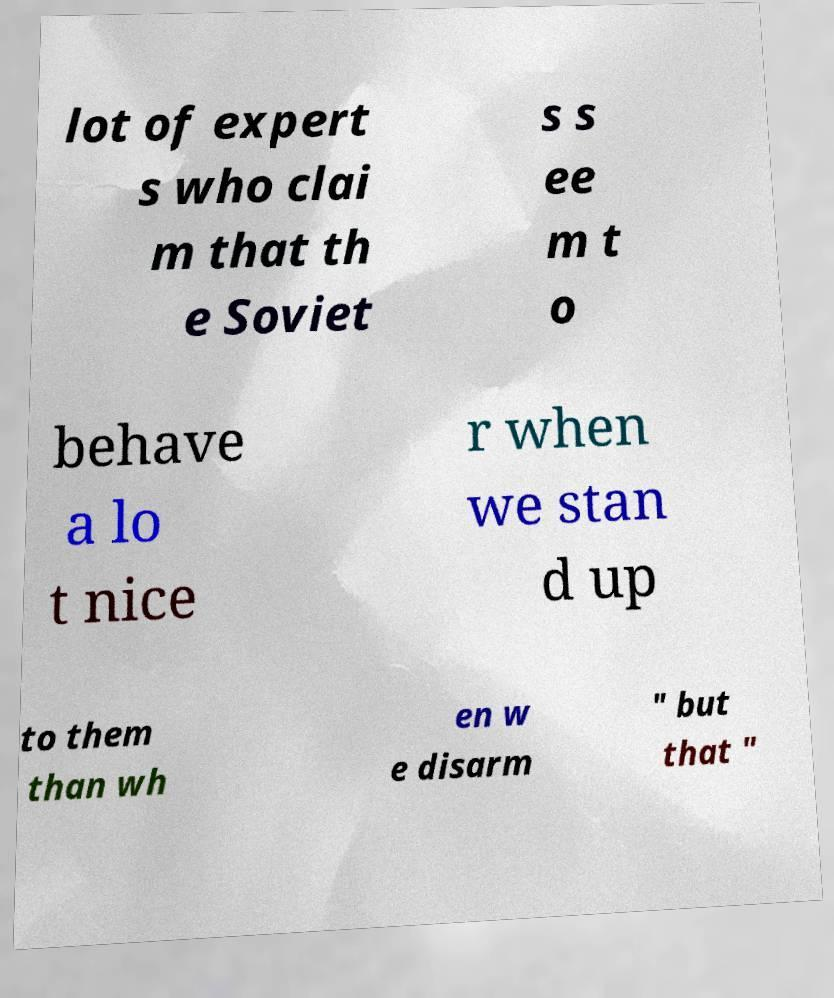Could you extract and type out the text from this image? lot of expert s who clai m that th e Soviet s s ee m t o behave a lo t nice r when we stan d up to them than wh en w e disarm " but that " 